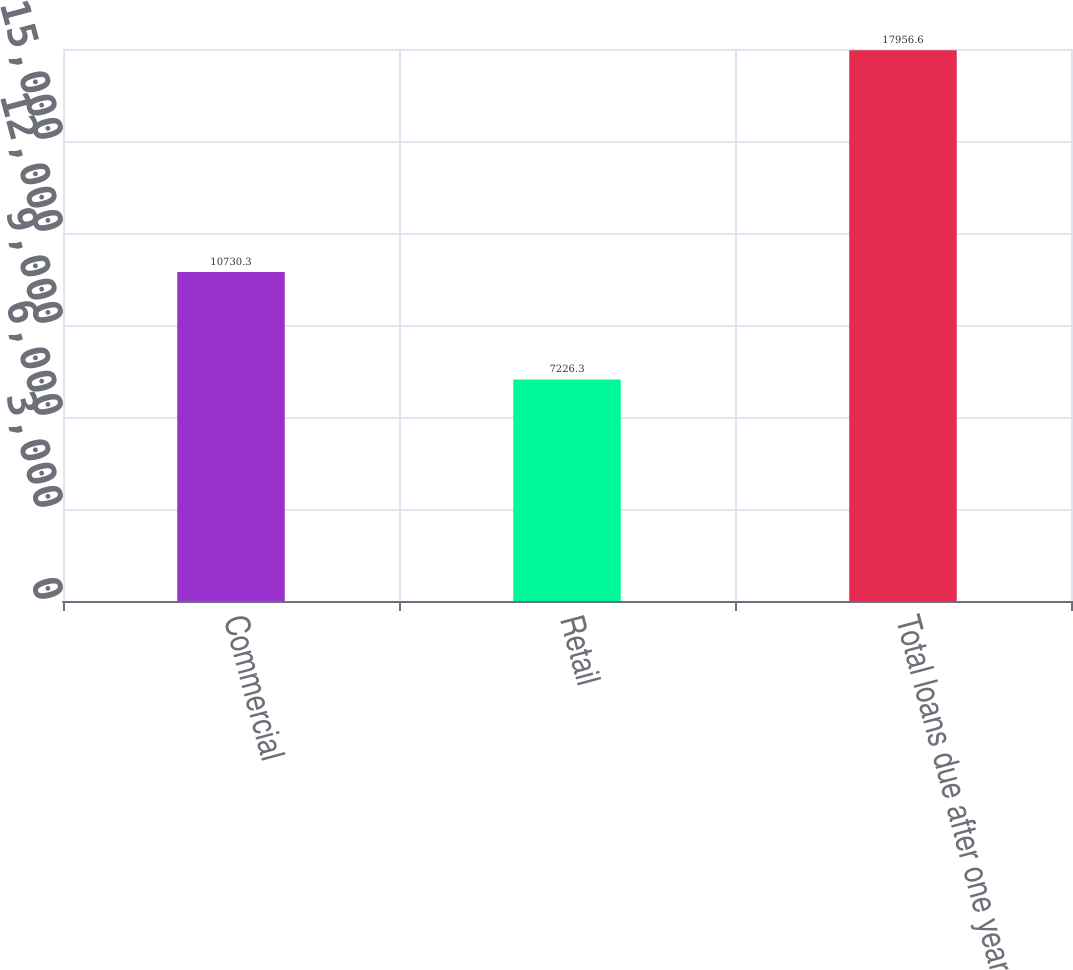Convert chart to OTSL. <chart><loc_0><loc_0><loc_500><loc_500><bar_chart><fcel>Commercial<fcel>Retail<fcel>Total loans due after one year<nl><fcel>10730.3<fcel>7226.3<fcel>17956.6<nl></chart> 